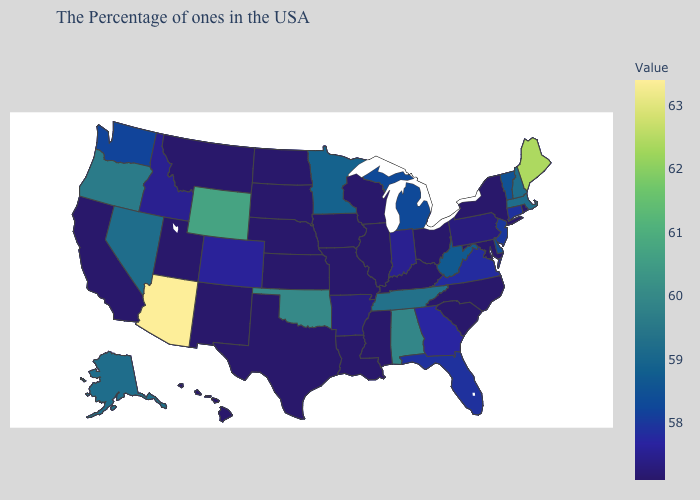Does Mississippi have the lowest value in the South?
Quick response, please. Yes. Does Arizona have a higher value than North Dakota?
Give a very brief answer. Yes. Which states have the lowest value in the South?
Be succinct. Maryland, North Carolina, South Carolina, Kentucky, Mississippi, Louisiana, Texas. Does Washington have a lower value than Wyoming?
Keep it brief. Yes. Is the legend a continuous bar?
Keep it brief. Yes. Does Arizona have the highest value in the USA?
Write a very short answer. Yes. 